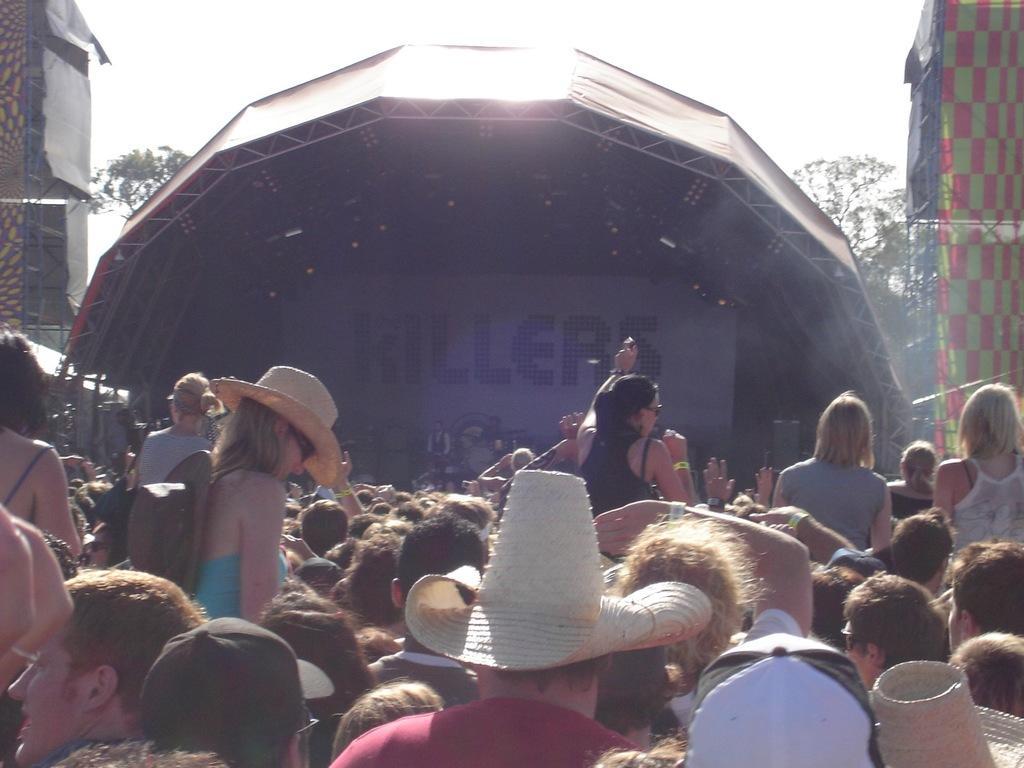Please provide a concise description of this image. In the foreground of this image, there are people wearing hats and caps on their heads. In the background, there is a stage, on either side there are banners to the pole like structures, trees and the sky. 